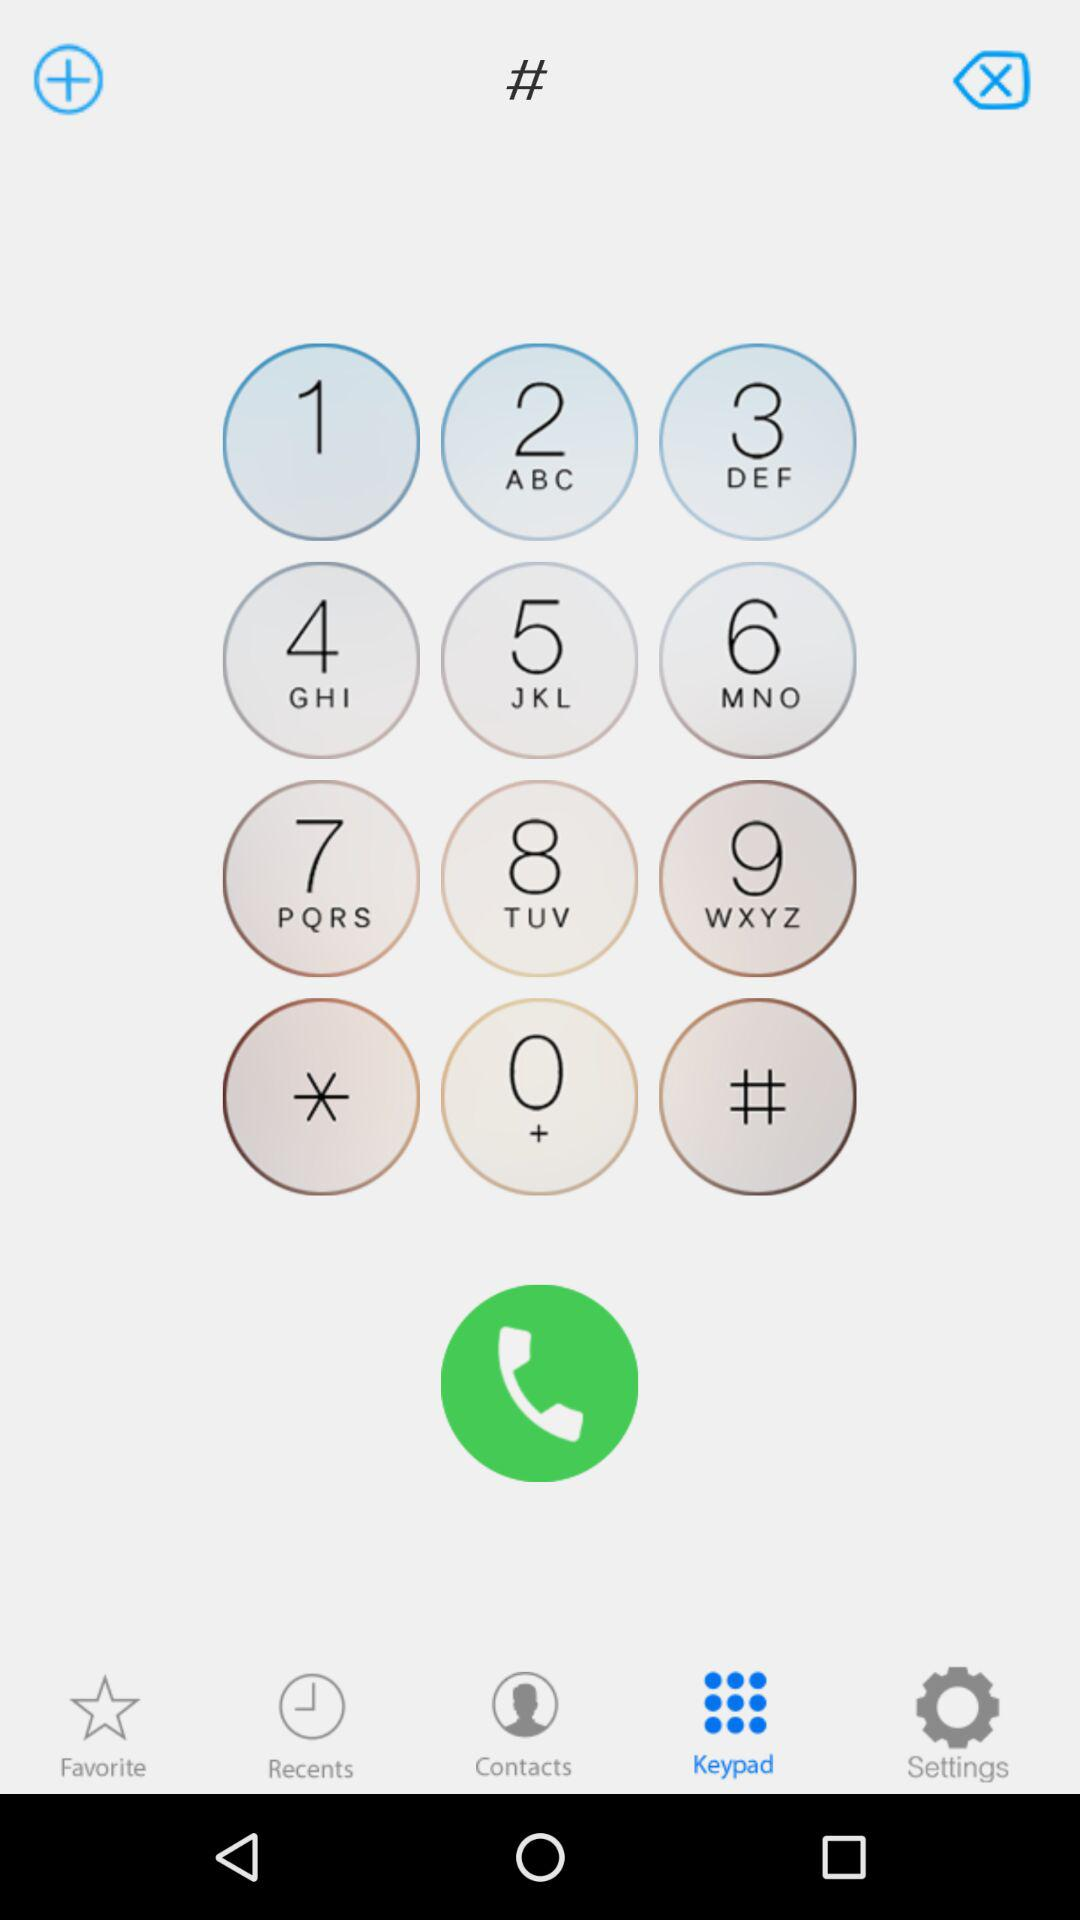Which tab has been selected? The tab that has been selected is "Keypad". 